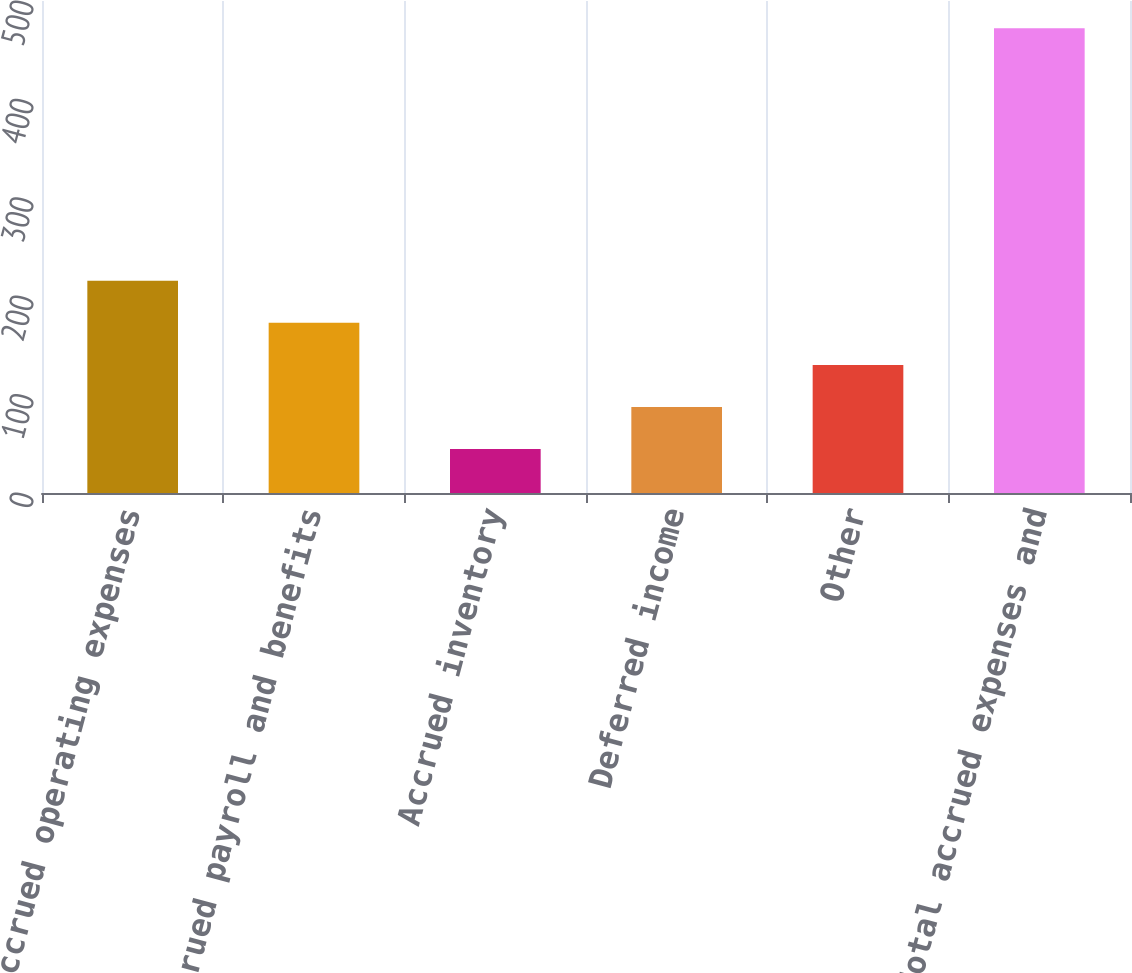<chart> <loc_0><loc_0><loc_500><loc_500><bar_chart><fcel>Accrued operating expenses<fcel>Accrued payroll and benefits<fcel>Accrued inventory<fcel>Deferred income<fcel>Other<fcel>Total accrued expenses and<nl><fcel>215.68<fcel>172.91<fcel>44.6<fcel>87.37<fcel>130.14<fcel>472.3<nl></chart> 